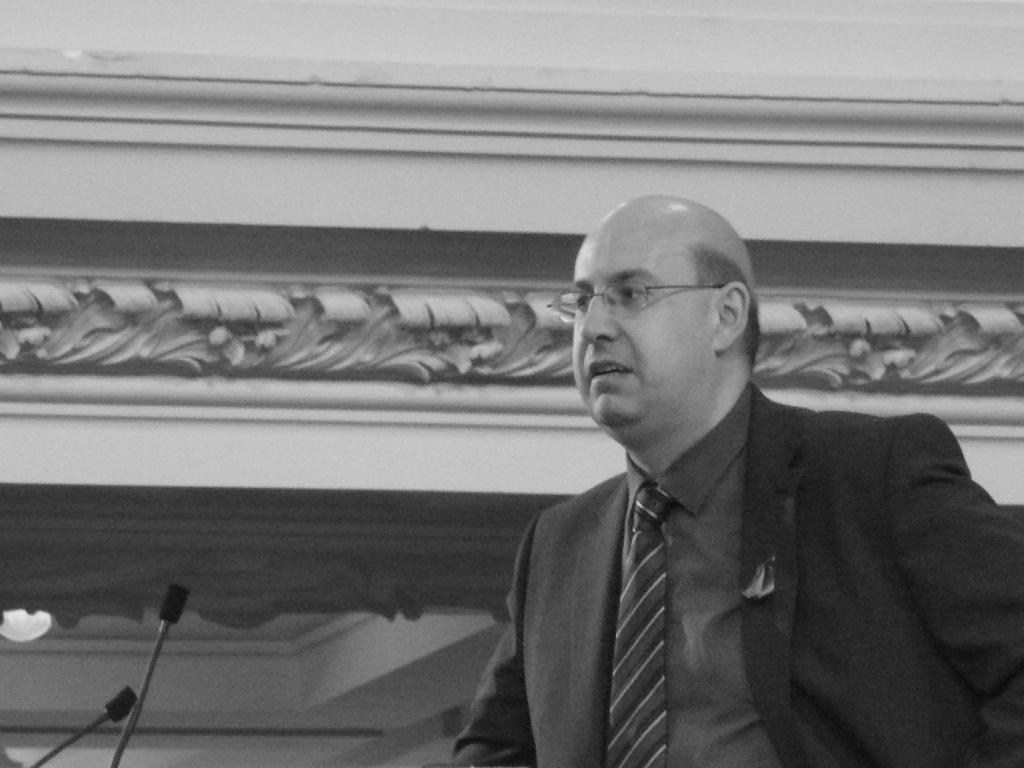How would you summarize this image in a sentence or two? On the right side of the image there is a person. In front of him there are two mikes. Behind him there is a wall and there is a lamp on the bottom left of the image. 